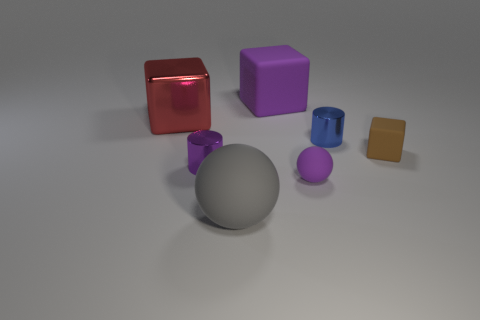Add 3 shiny cubes. How many objects exist? 10 Subtract all cylinders. How many objects are left? 5 Subtract all small yellow metal cylinders. Subtract all matte things. How many objects are left? 3 Add 3 small objects. How many small objects are left? 7 Add 3 big green shiny blocks. How many big green shiny blocks exist? 3 Subtract 0 green blocks. How many objects are left? 7 